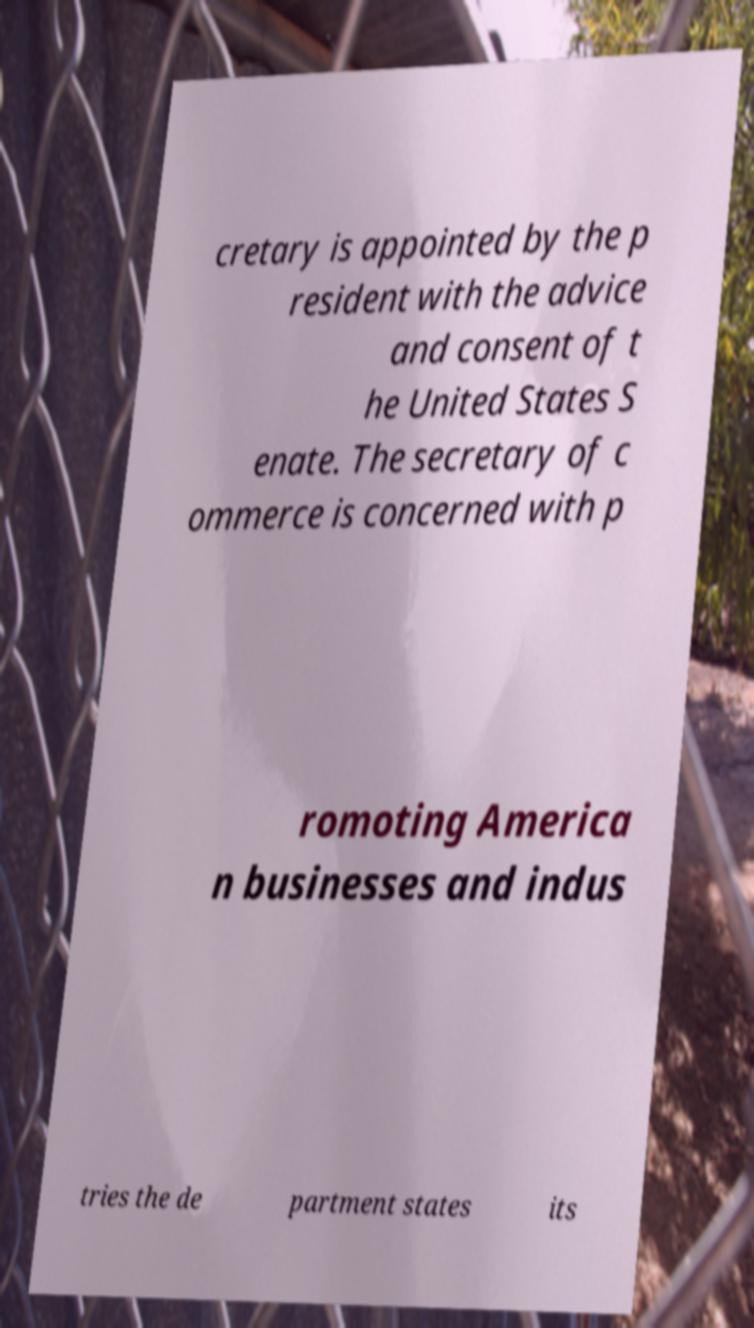For documentation purposes, I need the text within this image transcribed. Could you provide that? cretary is appointed by the p resident with the advice and consent of t he United States S enate. The secretary of c ommerce is concerned with p romoting America n businesses and indus tries the de partment states its 